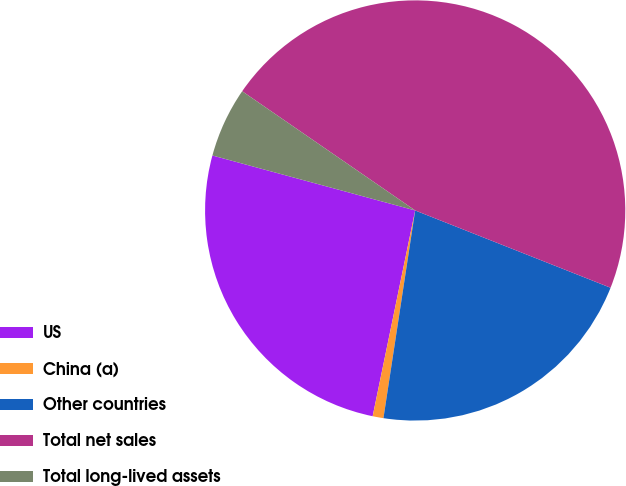<chart> <loc_0><loc_0><loc_500><loc_500><pie_chart><fcel>US<fcel>China (a)<fcel>Other countries<fcel>Total net sales<fcel>Total long-lived assets<nl><fcel>25.97%<fcel>0.83%<fcel>21.42%<fcel>46.39%<fcel>5.39%<nl></chart> 